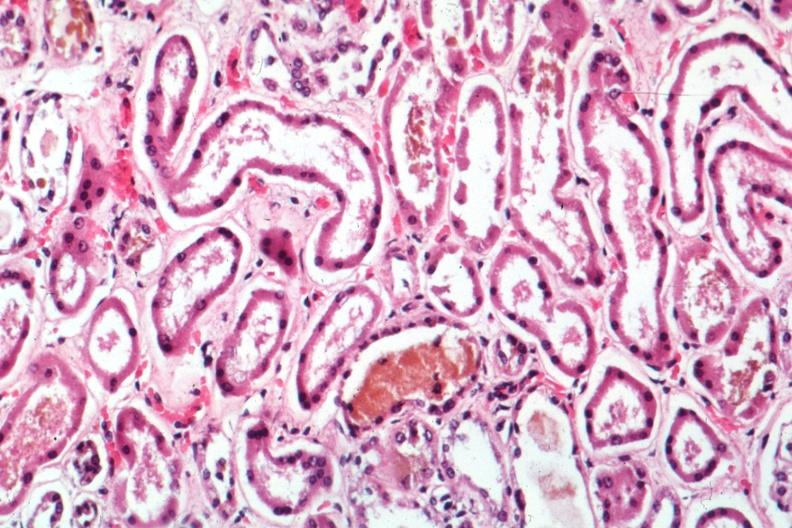what is present?
Answer the question using a single word or phrase. Kidney 